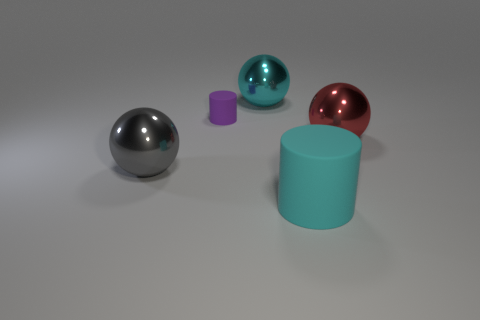Subtract all cyan metallic spheres. How many spheres are left? 2 Add 2 small purple spheres. How many objects exist? 7 Subtract 1 cylinders. How many cylinders are left? 1 Subtract all cyan cylinders. How many cylinders are left? 1 Subtract all spheres. How many objects are left? 2 Subtract 0 green spheres. How many objects are left? 5 Subtract all yellow spheres. Subtract all gray cubes. How many spheres are left? 3 Subtract all green metallic things. Subtract all small purple things. How many objects are left? 4 Add 1 tiny things. How many tiny things are left? 2 Add 1 tiny red shiny things. How many tiny red shiny things exist? 1 